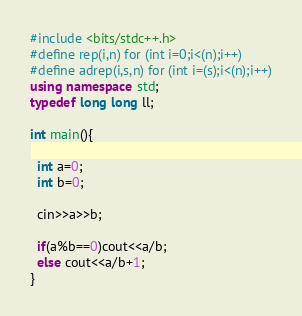Convert code to text. <code><loc_0><loc_0><loc_500><loc_500><_C++_>#include <bits/stdc++.h>
#define rep(i,n) for (int i=0;i<(n);i++)
#define adrep(i,s,n) for (int i=(s);i<(n);i++)
using namespace std;
typedef long long ll;

int main(){

  int a=0;
  int b=0;
  
  cin>>a>>b;
  
  if(a%b==0)cout<<a/b;
  else cout<<a/b+1;
}</code> 